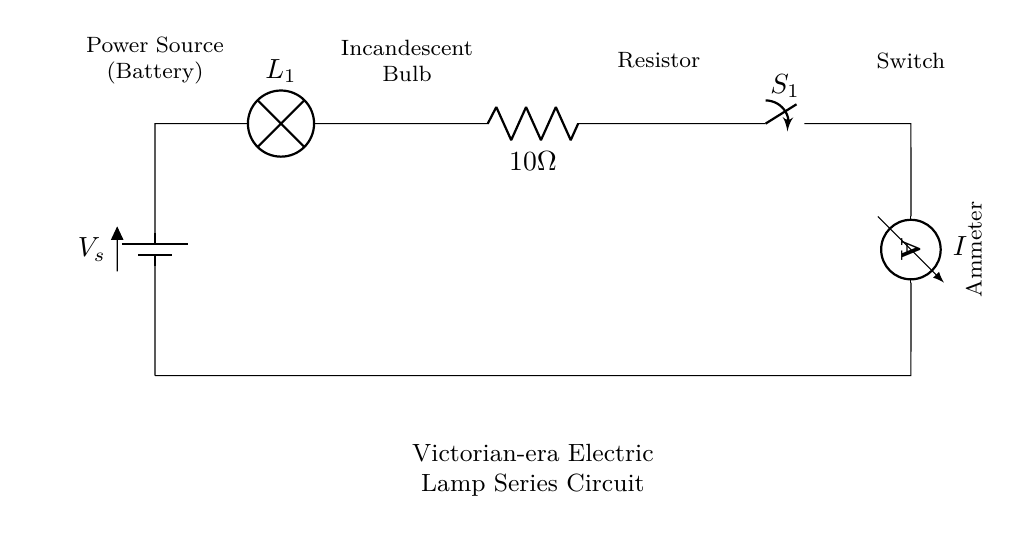What type of circuit is depicted? The circuit is a series circuit, which is identified by the components being connected in a single loop, meaning all current passes through each component sequentially.
Answer: series circuit What component is used to measure current? The component used to measure current is an ammeter, which is positioned in series to allow all current to flow through it, providing an accurate measurement.
Answer: ammeter What is the resistance value in the circuit? The resistance value is indicated next to the resistor component, which is labeled as ten ohms, reflecting the opposition to current flow within this part of the circuit.
Answer: 10 ohm How many components are in the circuit? The circuit includes five components: a battery, a lamp, a resistor, a switch, and an ammeter, counted based on the visual representation in the diagram.
Answer: five If the voltage is 10 volts, what is the current in the circuit? In a series circuit, the current can be calculated using Ohm’s law, where current equals voltage divided by resistance. Given the voltage of 10 volts and the total resistance of 10 ohms, the current would be 1 amp.
Answer: 1 amp What happens if the switch is open? If the switch is open, it breaks the continuity of the circuit, preventing current from flowing through all components, thus the circuit would stop functioning completely.
Answer: no current 